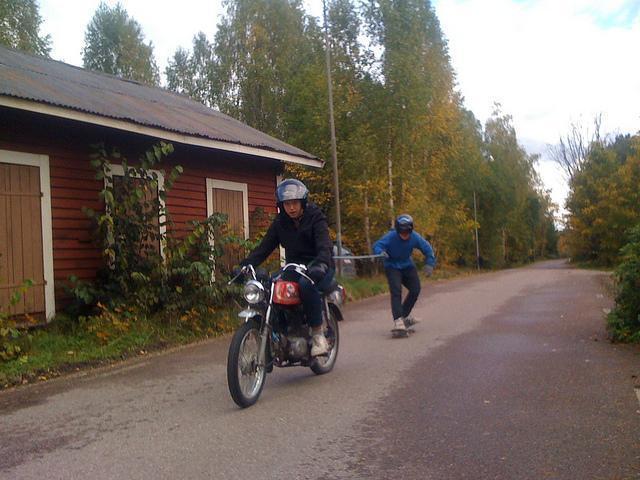How many people are there?
Give a very brief answer. 2. 